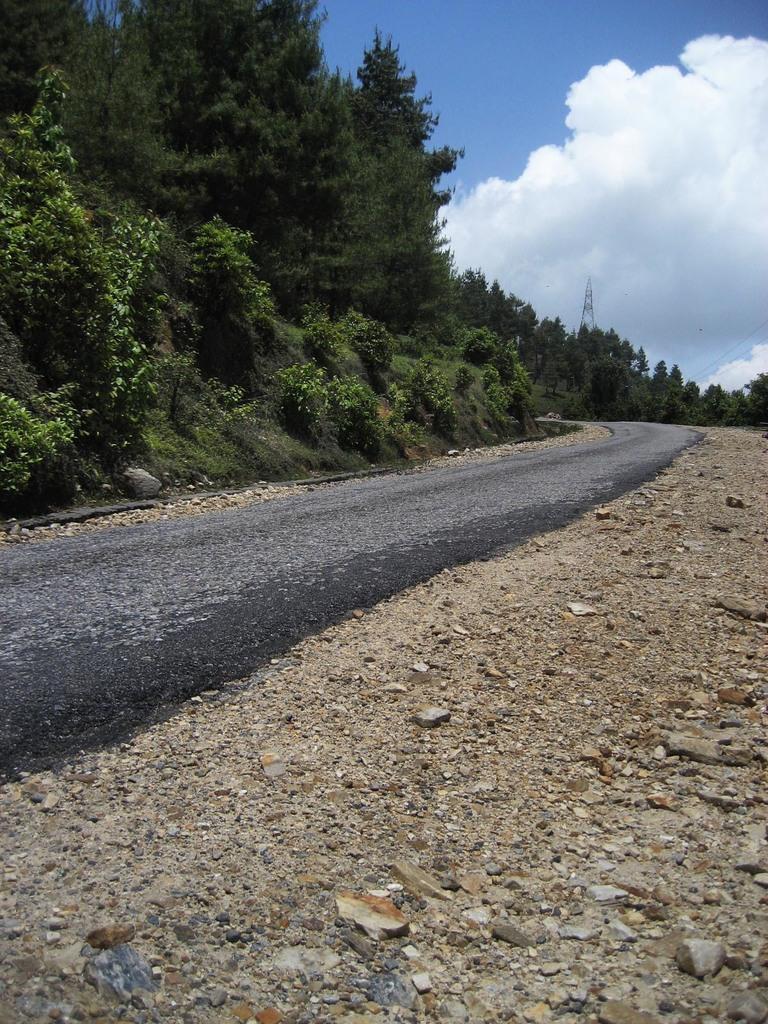In one or two sentences, can you explain what this image depicts? In this picture we can see some stones and road at the bottom, in the background there are some trees, we can see the sky and clouds at the top of the picture. 